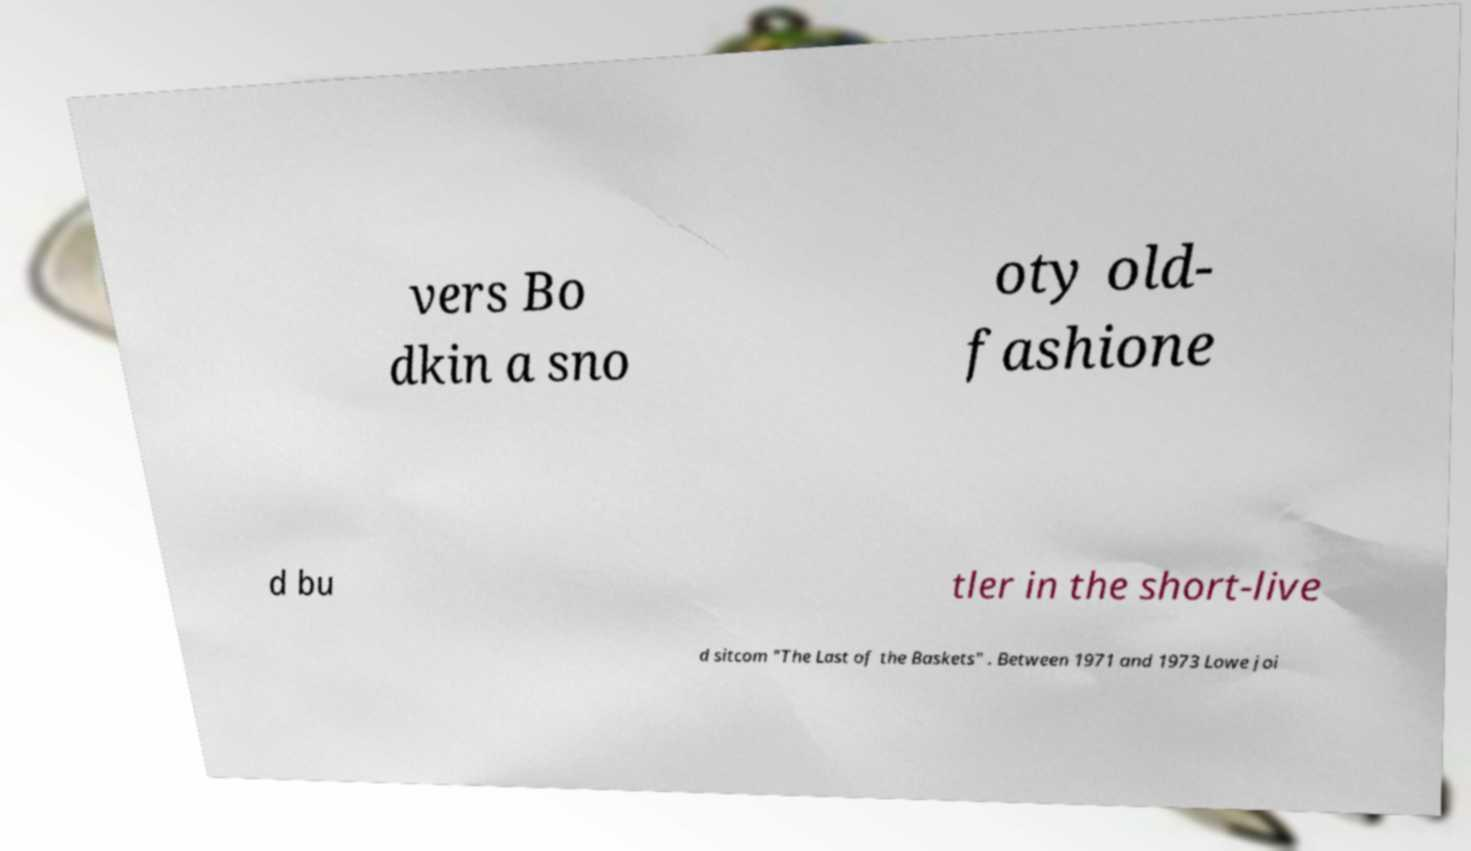What messages or text are displayed in this image? I need them in a readable, typed format. vers Bo dkin a sno oty old- fashione d bu tler in the short-live d sitcom "The Last of the Baskets" . Between 1971 and 1973 Lowe joi 